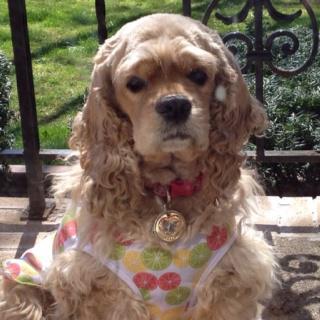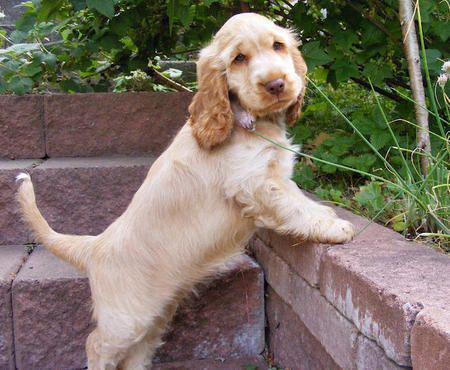The first image is the image on the left, the second image is the image on the right. Considering the images on both sides, is "Each image contains at least two cocker spaniels, and at least one image shows cocker spaniels sitting upright and looking upward." valid? Answer yes or no. No. The first image is the image on the left, the second image is the image on the right. For the images shown, is this caption "The image on the right contains exactly two dogs." true? Answer yes or no. No. 